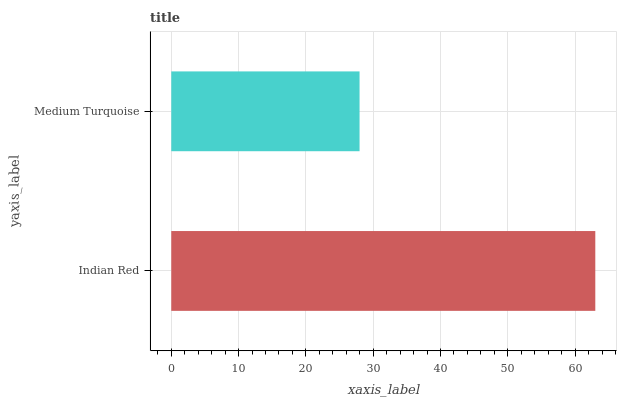Is Medium Turquoise the minimum?
Answer yes or no. Yes. Is Indian Red the maximum?
Answer yes or no. Yes. Is Medium Turquoise the maximum?
Answer yes or no. No. Is Indian Red greater than Medium Turquoise?
Answer yes or no. Yes. Is Medium Turquoise less than Indian Red?
Answer yes or no. Yes. Is Medium Turquoise greater than Indian Red?
Answer yes or no. No. Is Indian Red less than Medium Turquoise?
Answer yes or no. No. Is Indian Red the high median?
Answer yes or no. Yes. Is Medium Turquoise the low median?
Answer yes or no. Yes. Is Medium Turquoise the high median?
Answer yes or no. No. Is Indian Red the low median?
Answer yes or no. No. 